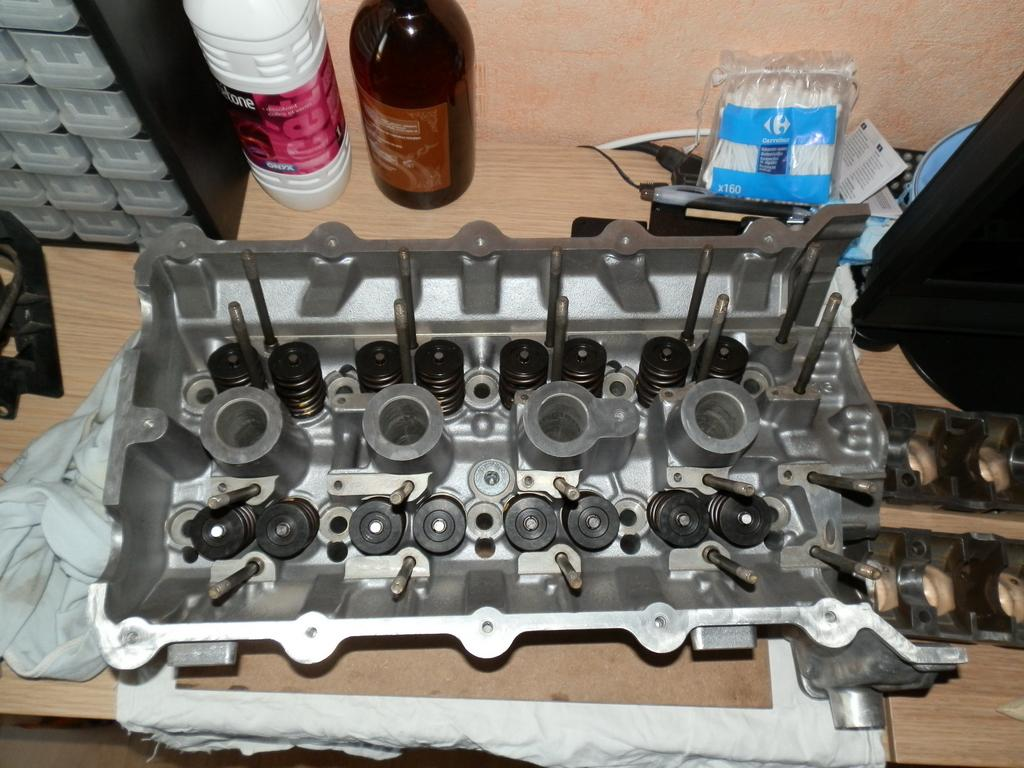What is the main object in the image? There is a machine in the image. Where is the machine located? The machine is placed on a table. What else can be seen in the background of the image? There are two bottles in the background of the image. What type of coat is the machine wearing in the image? There is no coat present in the image, as the machine is an inanimate object and does not wear clothing. 